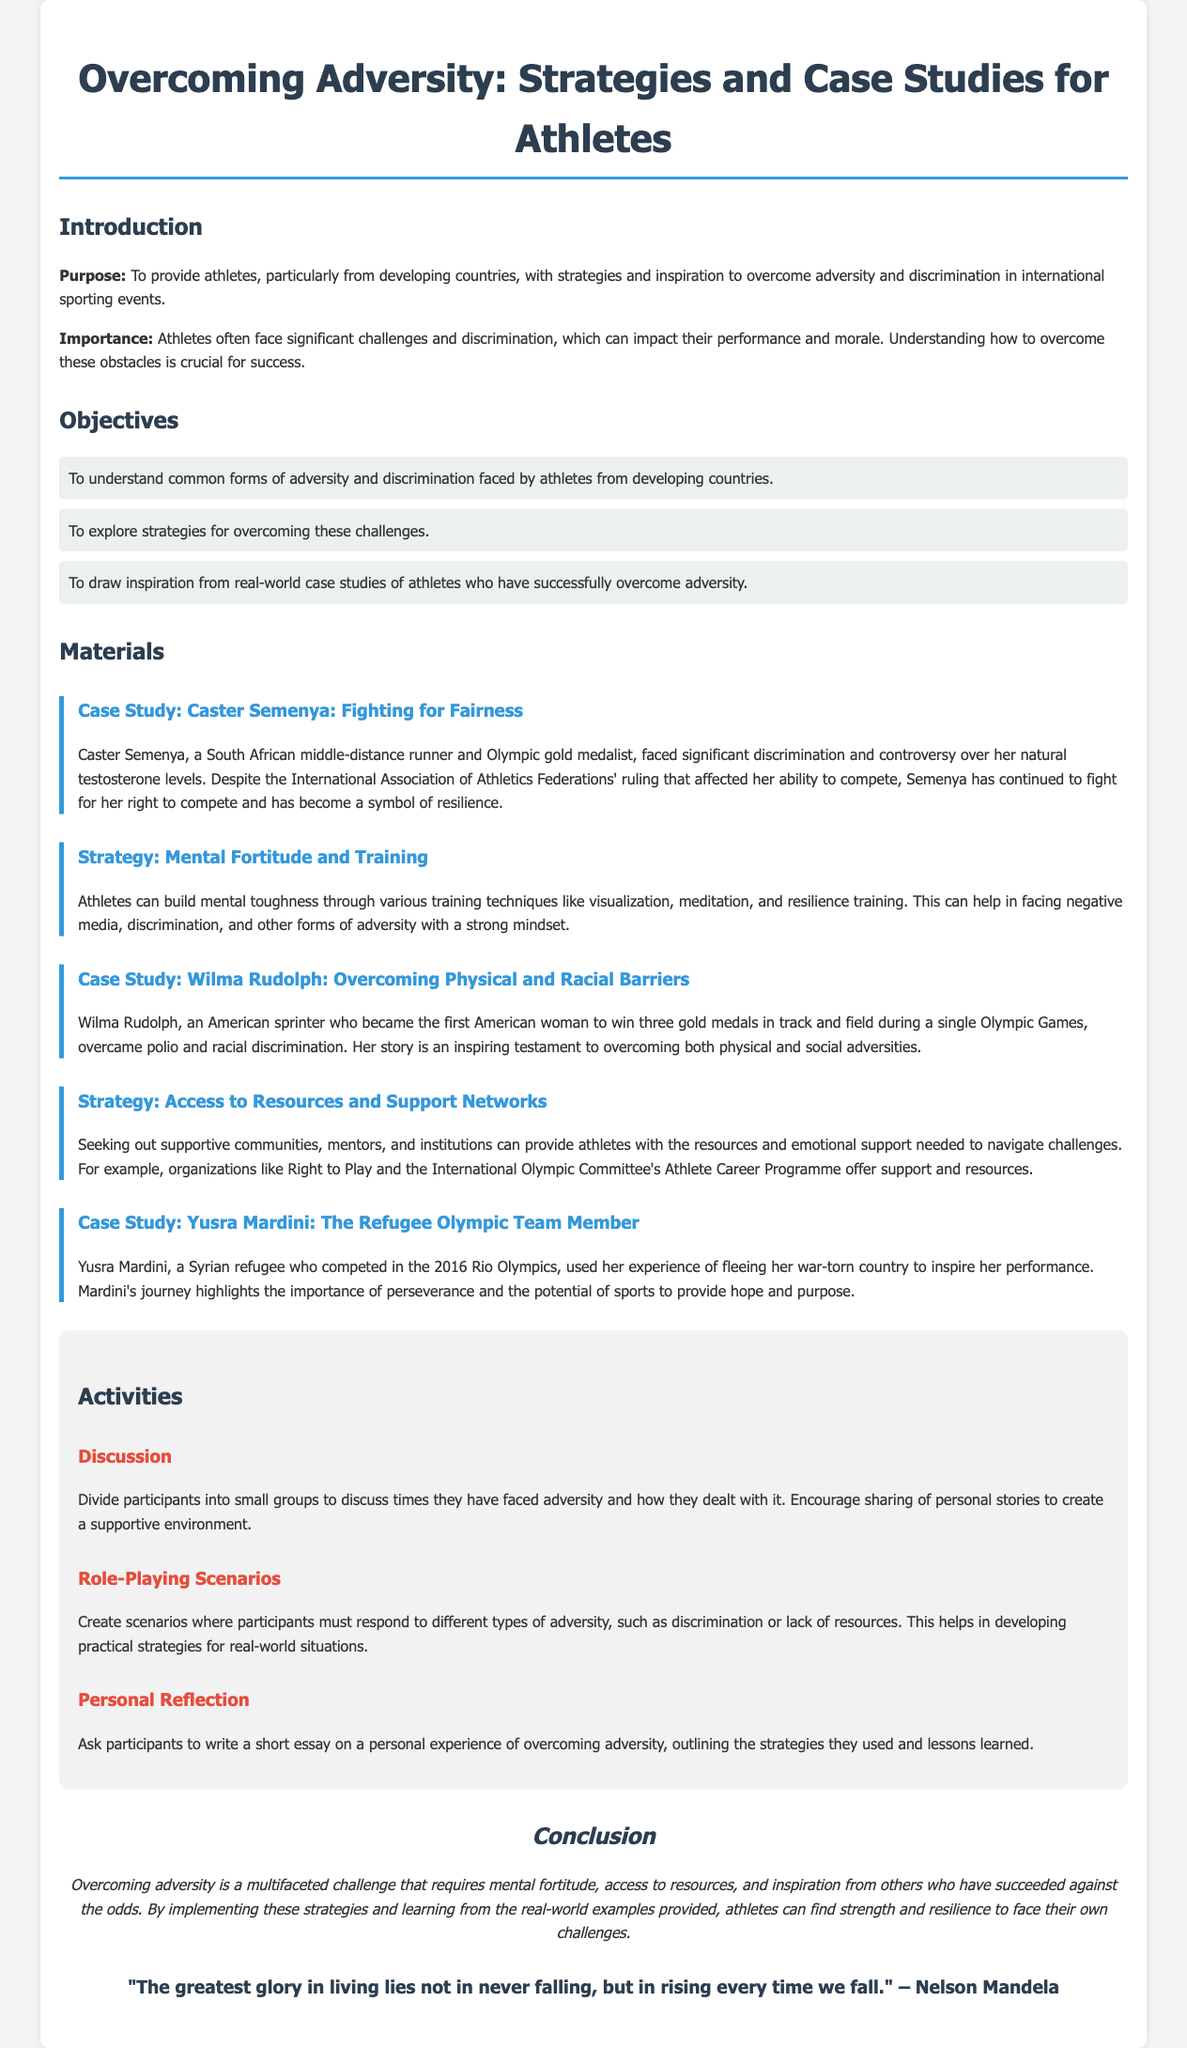What is the purpose of the document? The purpose is to provide athletes, particularly from developing countries, with strategies and inspiration to overcome adversity and discrimination in international sporting events.
Answer: To provide athletes, particularly from developing countries, with strategies and inspiration to overcome adversity and discrimination in international sporting events Who is the case study on Caster Semenya about? The case study is about Caster Semenya, a South African middle-distance runner and Olympic gold medalist, who faced discrimination over her natural testosterone levels.
Answer: Caster Semenya What strategies are mentioned for building mental toughness? Techniques like visualization, meditation, and resilience training are mentioned.
Answer: Visualization, meditation, and resilience training How many gold medals did Wilma Rudolph win in a single Olympic Games? Wilma Rudolph won three gold medals in track and field during a single Olympic Games.
Answer: Three Which athlete's story highlights the experience of a refugee? The case study on Yusra Mardini, a Syrian refugee who competed in the 2016 Rio Olympics, highlights this experience.
Answer: Yusra Mardini What is one of the activities suggested for participants? One suggested activity is to have participants write a short essay on a personal experience of overcoming adversity.
Answer: Personal Reflection What is the significance of the quote by Nelson Mandela at the end of the document? The quote emphasizes the importance of resilience and the ability to rise after failure.
Answer: Importance of resilience What type of resources can help athletes navigate challenges? Seeking out supportive communities, mentors, and institutions can help athletes navigate challenges.
Answer: Supportive communities, mentors, and institutions 